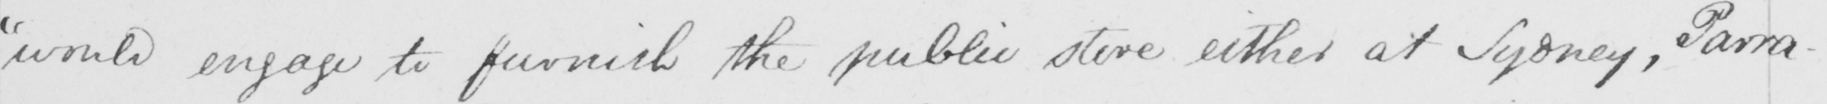Please transcribe the handwritten text in this image. "would engage to furnish the public store either at Sydney, Parra- 